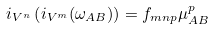Convert formula to latex. <formula><loc_0><loc_0><loc_500><loc_500>i _ { V ^ { n } } \left ( i _ { V ^ { m } } ( \omega _ { A B } ) \right ) = f _ { m n p } \mu ^ { p } _ { A B }</formula> 